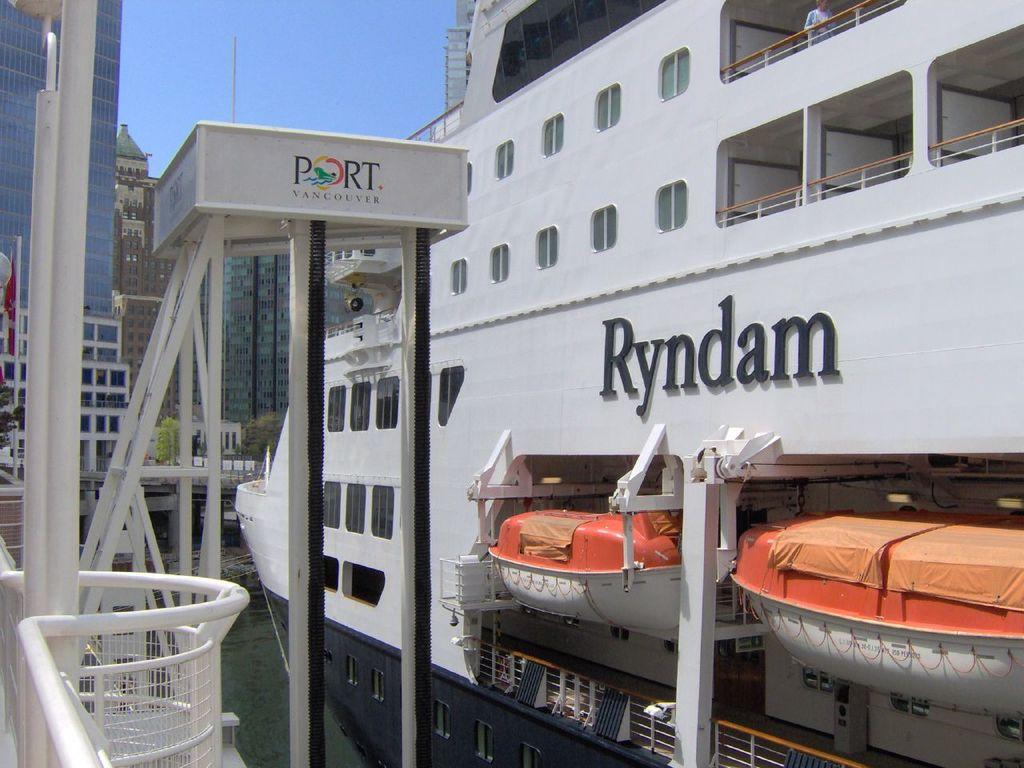What word is above the boats?
Give a very brief answer. Ryndam. What city is this the port of?
Your response must be concise. Vancouver. 